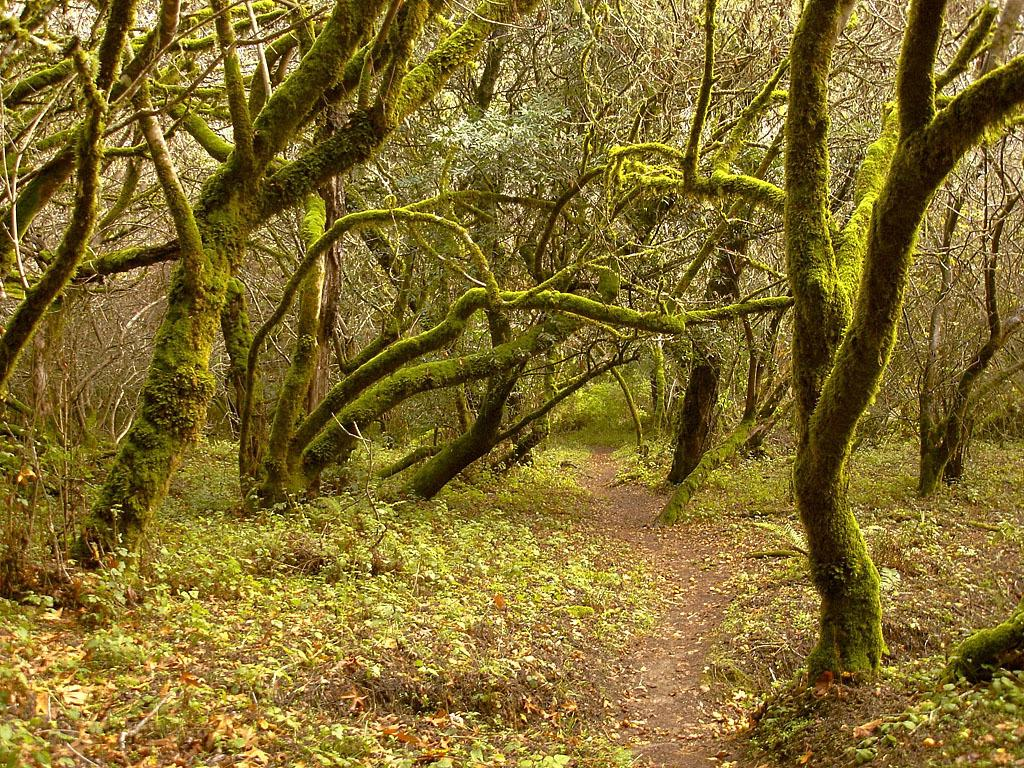What type of vegetation can be seen in the image? There are trees and plants in the image. What feature of the trees is visible in the image? The trees have branches in the image. Can you describe the texture of the trees? The bark of a tree is visible in the image. What type of path is present in the image? There is a pathway in the image. Where is the bean located in the image? There is no bean present in the image. What type of cemetery can be seen in the image? There is no cemetery present in the image. 